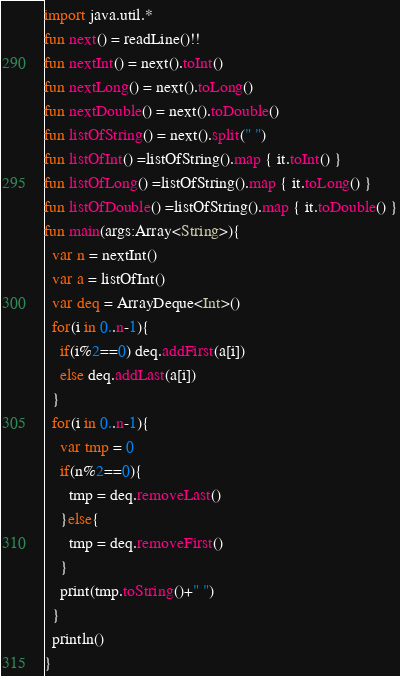<code> <loc_0><loc_0><loc_500><loc_500><_Kotlin_>import java.util.*
fun next() = readLine()!!
fun nextInt() = next().toInt()
fun nextLong() = next().toLong()
fun nextDouble() = next().toDouble()
fun listOfString() = next().split(" ")
fun listOfInt() =listOfString().map { it.toInt() }
fun listOfLong() =listOfString().map { it.toLong() }
fun listOfDouble() =listOfString().map { it.toDouble() }
fun main(args:Array<String>){
  var n = nextInt()
  var a = listOfInt()
  var deq = ArrayDeque<Int>()
  for(i in 0..n-1){
    if(i%2==0) deq.addFirst(a[i])
    else deq.addLast(a[i])
  }
  for(i in 0..n-1){
    var tmp = 0
    if(n%2==0){
      tmp = deq.removeLast()
    }else{
      tmp = deq.removeFirst()
    }
    print(tmp.toString()+" ")
  }
  println()
}
</code> 